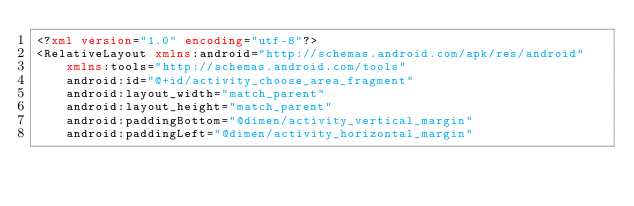Convert code to text. <code><loc_0><loc_0><loc_500><loc_500><_XML_><?xml version="1.0" encoding="utf-8"?>
<RelativeLayout xmlns:android="http://schemas.android.com/apk/res/android"
    xmlns:tools="http://schemas.android.com/tools"
    android:id="@+id/activity_choose_area_fragment"
    android:layout_width="match_parent"
    android:layout_height="match_parent"
    android:paddingBottom="@dimen/activity_vertical_margin"
    android:paddingLeft="@dimen/activity_horizontal_margin"</code> 